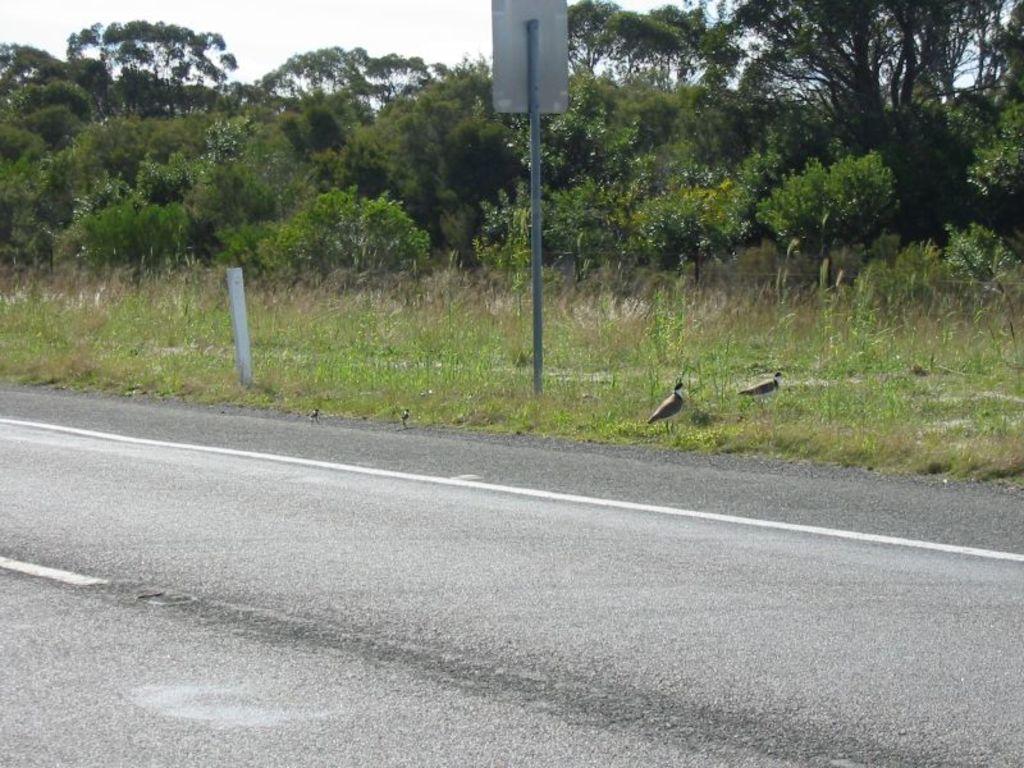How would you summarize this image in a sentence or two? In this image I can see the road, a metal pole and a board, some grass, few birds which are black and white in color and few trees. In the background I can see the sky. 